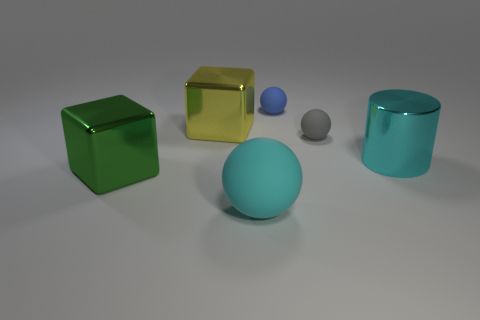What number of rubber spheres are behind the cyan cylinder?
Keep it short and to the point. 2. What is the size of the thing behind the metallic cube behind the big cyan object that is behind the cyan rubber sphere?
Offer a terse response. Small. Is the shape of the blue thing the same as the large object that is right of the cyan matte sphere?
Ensure brevity in your answer.  No. The blue sphere that is made of the same material as the gray sphere is what size?
Your answer should be very brief. Small. What is the material of the large cube that is in front of the cyan object that is right of the ball that is to the left of the tiny blue ball?
Your answer should be very brief. Metal. What number of metallic things are either large balls or tiny blue things?
Ensure brevity in your answer.  0. Does the shiny cylinder have the same color as the big ball?
Provide a short and direct response. Yes. How many objects are matte balls or cyan things that are on the left side of the tiny gray matte object?
Offer a very short reply. 3. Is the size of the rubber sphere right of the blue matte thing the same as the yellow metal cube?
Keep it short and to the point. No. What number of other things are there of the same shape as the cyan matte thing?
Give a very brief answer. 2. 